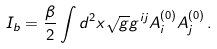<formula> <loc_0><loc_0><loc_500><loc_500>I _ { b } = \frac { \beta } { 2 } \int d ^ { 2 } x \sqrt { g } g ^ { i j } A ^ { ( 0 ) } _ { i } A ^ { ( 0 ) } _ { j } \, .</formula> 